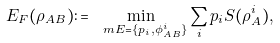Convert formula to latex. <formula><loc_0><loc_0><loc_500><loc_500>E _ { F } ( \rho _ { A B } ) \colon = \min _ { \ m E = \{ p _ { i } , \phi _ { A B } ^ { i } \} } \sum _ { i } p _ { i } S ( \rho _ { A } ^ { i } ) ,</formula> 